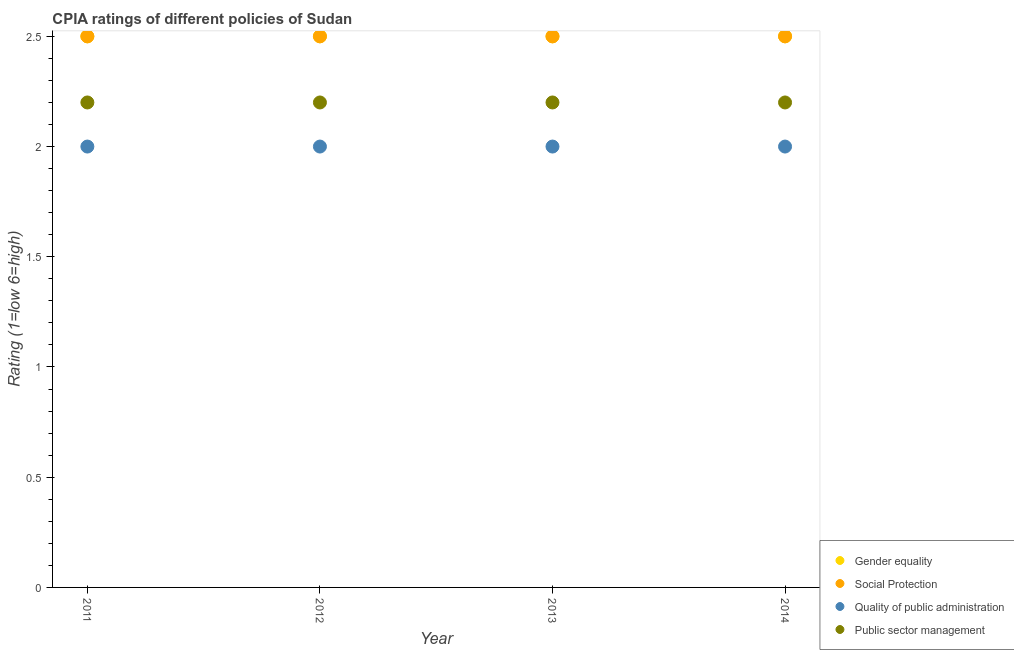Is the number of dotlines equal to the number of legend labels?
Give a very brief answer. Yes. What is the cpia rating of social protection in 2013?
Give a very brief answer. 2.5. Across all years, what is the maximum cpia rating of quality of public administration?
Provide a short and direct response. 2. In which year was the cpia rating of social protection maximum?
Your answer should be compact. 2011. What is the difference between the cpia rating of quality of public administration in 2011 and that in 2014?
Provide a short and direct response. 0. What is the difference between the cpia rating of social protection in 2011 and the cpia rating of public sector management in 2012?
Your answer should be compact. 0.3. What is the average cpia rating of public sector management per year?
Give a very brief answer. 2.2. In the year 2011, what is the difference between the cpia rating of quality of public administration and cpia rating of public sector management?
Your answer should be very brief. -0.2. In how many years, is the cpia rating of gender equality greater than 0.1?
Ensure brevity in your answer.  4. What is the ratio of the cpia rating of public sector management in 2012 to that in 2014?
Provide a short and direct response. 1. What is the difference between the highest and the second highest cpia rating of quality of public administration?
Provide a succinct answer. 0. What is the difference between the highest and the lowest cpia rating of quality of public administration?
Give a very brief answer. 0. In how many years, is the cpia rating of quality of public administration greater than the average cpia rating of quality of public administration taken over all years?
Your response must be concise. 0. Is the sum of the cpia rating of quality of public administration in 2012 and 2013 greater than the maximum cpia rating of gender equality across all years?
Provide a succinct answer. Yes. Does the cpia rating of social protection monotonically increase over the years?
Your response must be concise. No. Is the cpia rating of gender equality strictly less than the cpia rating of social protection over the years?
Offer a very short reply. No. What is the difference between two consecutive major ticks on the Y-axis?
Give a very brief answer. 0.5. Are the values on the major ticks of Y-axis written in scientific E-notation?
Keep it short and to the point. No. Does the graph contain grids?
Provide a succinct answer. No. How many legend labels are there?
Your response must be concise. 4. How are the legend labels stacked?
Your response must be concise. Vertical. What is the title of the graph?
Your answer should be very brief. CPIA ratings of different policies of Sudan. What is the label or title of the X-axis?
Make the answer very short. Year. What is the label or title of the Y-axis?
Ensure brevity in your answer.  Rating (1=low 6=high). What is the Rating (1=low 6=high) in Gender equality in 2011?
Keep it short and to the point. 2.5. What is the Rating (1=low 6=high) in Gender equality in 2012?
Provide a short and direct response. 2.5. What is the Rating (1=low 6=high) in Social Protection in 2012?
Keep it short and to the point. 2.5. What is the Rating (1=low 6=high) of Quality of public administration in 2012?
Provide a succinct answer. 2. What is the Rating (1=low 6=high) of Public sector management in 2012?
Provide a short and direct response. 2.2. What is the Rating (1=low 6=high) of Gender equality in 2013?
Keep it short and to the point. 2.5. What is the Rating (1=low 6=high) in Public sector management in 2013?
Ensure brevity in your answer.  2.2. What is the Rating (1=low 6=high) in Gender equality in 2014?
Offer a terse response. 2.5. What is the Rating (1=low 6=high) in Social Protection in 2014?
Provide a succinct answer. 2.5. What is the Rating (1=low 6=high) in Public sector management in 2014?
Your response must be concise. 2.2. Across all years, what is the maximum Rating (1=low 6=high) in Social Protection?
Your answer should be very brief. 2.5. Across all years, what is the maximum Rating (1=low 6=high) in Quality of public administration?
Your answer should be very brief. 2. Across all years, what is the maximum Rating (1=low 6=high) of Public sector management?
Make the answer very short. 2.2. Across all years, what is the minimum Rating (1=low 6=high) of Gender equality?
Ensure brevity in your answer.  2.5. Across all years, what is the minimum Rating (1=low 6=high) of Social Protection?
Offer a terse response. 2.5. Across all years, what is the minimum Rating (1=low 6=high) in Quality of public administration?
Your response must be concise. 2. Across all years, what is the minimum Rating (1=low 6=high) of Public sector management?
Your answer should be compact. 2.2. What is the total Rating (1=low 6=high) in Gender equality in the graph?
Keep it short and to the point. 10. What is the total Rating (1=low 6=high) of Social Protection in the graph?
Your response must be concise. 10. What is the total Rating (1=low 6=high) of Public sector management in the graph?
Offer a very short reply. 8.8. What is the difference between the Rating (1=low 6=high) in Gender equality in 2011 and that in 2012?
Provide a succinct answer. 0. What is the difference between the Rating (1=low 6=high) in Public sector management in 2011 and that in 2014?
Make the answer very short. 0. What is the difference between the Rating (1=low 6=high) in Gender equality in 2012 and that in 2013?
Your response must be concise. 0. What is the difference between the Rating (1=low 6=high) of Social Protection in 2012 and that in 2013?
Your response must be concise. 0. What is the difference between the Rating (1=low 6=high) of Quality of public administration in 2012 and that in 2013?
Your answer should be compact. 0. What is the difference between the Rating (1=low 6=high) in Gender equality in 2012 and that in 2014?
Keep it short and to the point. 0. What is the difference between the Rating (1=low 6=high) in Quality of public administration in 2012 and that in 2014?
Give a very brief answer. 0. What is the difference between the Rating (1=low 6=high) of Gender equality in 2013 and that in 2014?
Make the answer very short. 0. What is the difference between the Rating (1=low 6=high) of Social Protection in 2013 and that in 2014?
Ensure brevity in your answer.  0. What is the difference between the Rating (1=low 6=high) of Quality of public administration in 2013 and that in 2014?
Your answer should be very brief. 0. What is the difference between the Rating (1=low 6=high) of Public sector management in 2013 and that in 2014?
Keep it short and to the point. 0. What is the difference between the Rating (1=low 6=high) in Gender equality in 2011 and the Rating (1=low 6=high) in Social Protection in 2012?
Offer a very short reply. 0. What is the difference between the Rating (1=low 6=high) in Gender equality in 2011 and the Rating (1=low 6=high) in Quality of public administration in 2012?
Your answer should be compact. 0.5. What is the difference between the Rating (1=low 6=high) of Social Protection in 2011 and the Rating (1=low 6=high) of Public sector management in 2012?
Make the answer very short. 0.3. What is the difference between the Rating (1=low 6=high) of Quality of public administration in 2011 and the Rating (1=low 6=high) of Public sector management in 2012?
Keep it short and to the point. -0.2. What is the difference between the Rating (1=low 6=high) of Gender equality in 2011 and the Rating (1=low 6=high) of Social Protection in 2013?
Give a very brief answer. 0. What is the difference between the Rating (1=low 6=high) in Gender equality in 2011 and the Rating (1=low 6=high) in Quality of public administration in 2013?
Provide a succinct answer. 0.5. What is the difference between the Rating (1=low 6=high) of Gender equality in 2011 and the Rating (1=low 6=high) of Public sector management in 2013?
Provide a short and direct response. 0.3. What is the difference between the Rating (1=low 6=high) of Gender equality in 2011 and the Rating (1=low 6=high) of Public sector management in 2014?
Your answer should be very brief. 0.3. What is the difference between the Rating (1=low 6=high) of Social Protection in 2011 and the Rating (1=low 6=high) of Quality of public administration in 2014?
Give a very brief answer. 0.5. What is the difference between the Rating (1=low 6=high) of Social Protection in 2011 and the Rating (1=low 6=high) of Public sector management in 2014?
Keep it short and to the point. 0.3. What is the difference between the Rating (1=low 6=high) in Gender equality in 2012 and the Rating (1=low 6=high) in Quality of public administration in 2013?
Your answer should be very brief. 0.5. What is the difference between the Rating (1=low 6=high) in Social Protection in 2012 and the Rating (1=low 6=high) in Quality of public administration in 2013?
Provide a succinct answer. 0.5. What is the difference between the Rating (1=low 6=high) in Social Protection in 2012 and the Rating (1=low 6=high) in Public sector management in 2013?
Your answer should be compact. 0.3. What is the difference between the Rating (1=low 6=high) in Gender equality in 2012 and the Rating (1=low 6=high) in Quality of public administration in 2014?
Provide a succinct answer. 0.5. What is the difference between the Rating (1=low 6=high) in Social Protection in 2012 and the Rating (1=low 6=high) in Quality of public administration in 2014?
Offer a very short reply. 0.5. What is the difference between the Rating (1=low 6=high) of Gender equality in 2013 and the Rating (1=low 6=high) of Quality of public administration in 2014?
Ensure brevity in your answer.  0.5. What is the difference between the Rating (1=low 6=high) in Gender equality in 2013 and the Rating (1=low 6=high) in Public sector management in 2014?
Offer a terse response. 0.3. What is the difference between the Rating (1=low 6=high) of Quality of public administration in 2013 and the Rating (1=low 6=high) of Public sector management in 2014?
Provide a succinct answer. -0.2. What is the average Rating (1=low 6=high) of Social Protection per year?
Give a very brief answer. 2.5. What is the average Rating (1=low 6=high) in Quality of public administration per year?
Offer a very short reply. 2. In the year 2011, what is the difference between the Rating (1=low 6=high) of Gender equality and Rating (1=low 6=high) of Quality of public administration?
Your answer should be compact. 0.5. In the year 2011, what is the difference between the Rating (1=low 6=high) of Gender equality and Rating (1=low 6=high) of Public sector management?
Offer a terse response. 0.3. In the year 2011, what is the difference between the Rating (1=low 6=high) in Social Protection and Rating (1=low 6=high) in Quality of public administration?
Your answer should be compact. 0.5. In the year 2011, what is the difference between the Rating (1=low 6=high) in Social Protection and Rating (1=low 6=high) in Public sector management?
Your answer should be very brief. 0.3. In the year 2012, what is the difference between the Rating (1=low 6=high) in Gender equality and Rating (1=low 6=high) in Quality of public administration?
Your answer should be very brief. 0.5. In the year 2012, what is the difference between the Rating (1=low 6=high) in Gender equality and Rating (1=low 6=high) in Public sector management?
Keep it short and to the point. 0.3. In the year 2012, what is the difference between the Rating (1=low 6=high) in Social Protection and Rating (1=low 6=high) in Quality of public administration?
Your answer should be very brief. 0.5. In the year 2013, what is the difference between the Rating (1=low 6=high) in Gender equality and Rating (1=low 6=high) in Quality of public administration?
Keep it short and to the point. 0.5. In the year 2013, what is the difference between the Rating (1=low 6=high) of Social Protection and Rating (1=low 6=high) of Public sector management?
Provide a succinct answer. 0.3. In the year 2014, what is the difference between the Rating (1=low 6=high) of Quality of public administration and Rating (1=low 6=high) of Public sector management?
Provide a succinct answer. -0.2. What is the ratio of the Rating (1=low 6=high) in Gender equality in 2011 to that in 2012?
Your response must be concise. 1. What is the ratio of the Rating (1=low 6=high) in Social Protection in 2011 to that in 2012?
Your answer should be very brief. 1. What is the ratio of the Rating (1=low 6=high) of Social Protection in 2011 to that in 2013?
Provide a succinct answer. 1. What is the ratio of the Rating (1=low 6=high) in Public sector management in 2011 to that in 2013?
Your answer should be very brief. 1. What is the ratio of the Rating (1=low 6=high) of Gender equality in 2011 to that in 2014?
Ensure brevity in your answer.  1. What is the ratio of the Rating (1=low 6=high) of Quality of public administration in 2011 to that in 2014?
Make the answer very short. 1. What is the ratio of the Rating (1=low 6=high) of Social Protection in 2012 to that in 2013?
Make the answer very short. 1. What is the ratio of the Rating (1=low 6=high) in Public sector management in 2012 to that in 2013?
Ensure brevity in your answer.  1. What is the ratio of the Rating (1=low 6=high) in Gender equality in 2012 to that in 2014?
Provide a succinct answer. 1. What is the ratio of the Rating (1=low 6=high) in Public sector management in 2012 to that in 2014?
Offer a very short reply. 1. What is the ratio of the Rating (1=low 6=high) of Gender equality in 2013 to that in 2014?
Your answer should be compact. 1. What is the ratio of the Rating (1=low 6=high) of Social Protection in 2013 to that in 2014?
Your answer should be compact. 1. What is the ratio of the Rating (1=low 6=high) of Quality of public administration in 2013 to that in 2014?
Make the answer very short. 1. What is the difference between the highest and the second highest Rating (1=low 6=high) of Social Protection?
Your answer should be compact. 0. What is the difference between the highest and the second highest Rating (1=low 6=high) in Quality of public administration?
Offer a very short reply. 0. What is the difference between the highest and the second highest Rating (1=low 6=high) of Public sector management?
Keep it short and to the point. 0. What is the difference between the highest and the lowest Rating (1=low 6=high) of Quality of public administration?
Provide a succinct answer. 0. What is the difference between the highest and the lowest Rating (1=low 6=high) in Public sector management?
Ensure brevity in your answer.  0. 